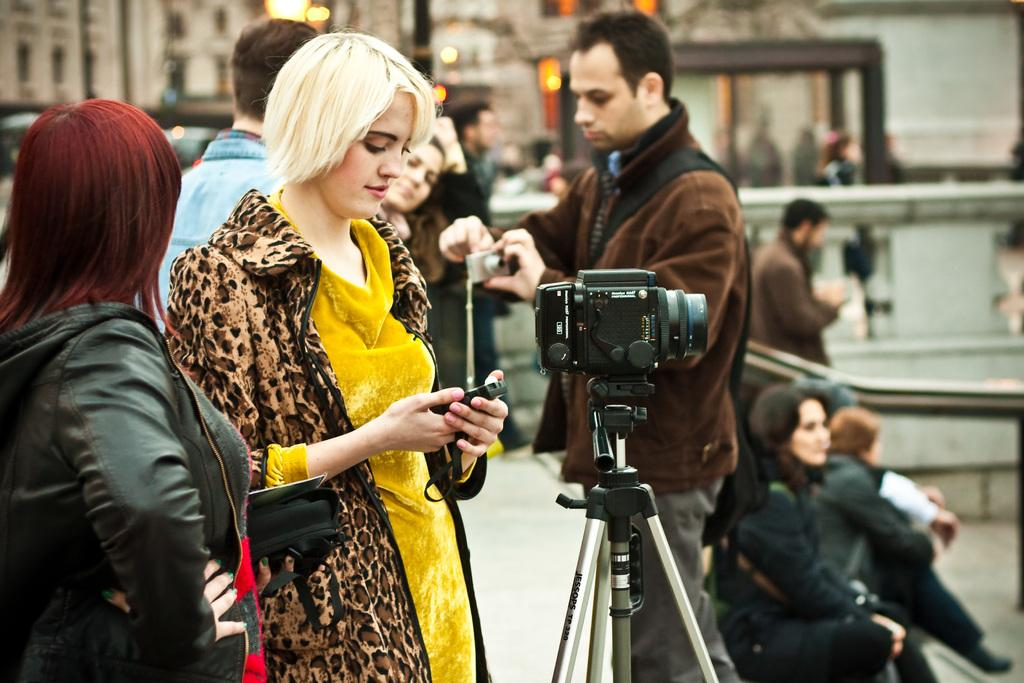What are the persons in the image doing? The persons in the image are standing and holding cameras and other devices. Are there any other positions that the persons are in? Yes, there are persons sitting in the image. Can you identify any specific device in the image? Yes, there is a camera visible in the image. What type of watch is the person wearing in the image? There is no watch visible in the image. How many stems are present in the image? There is no reference to stems in the image, so it is not possible to answer that question. 